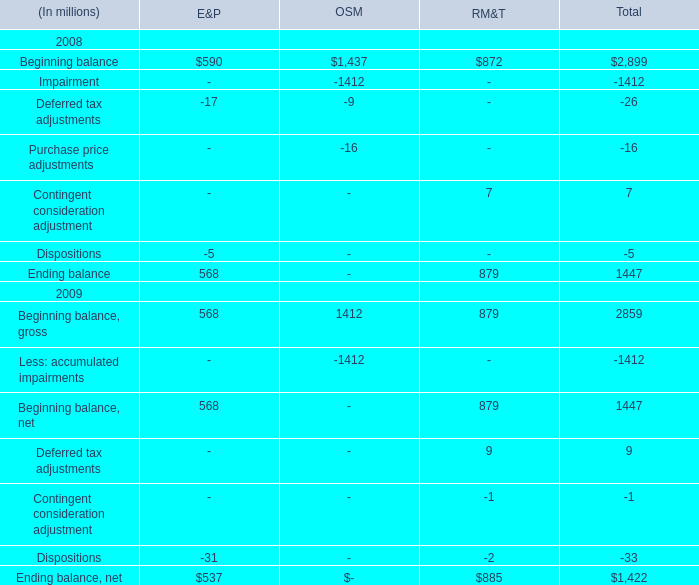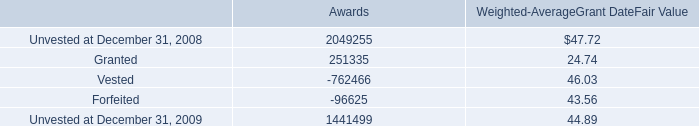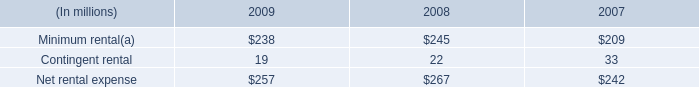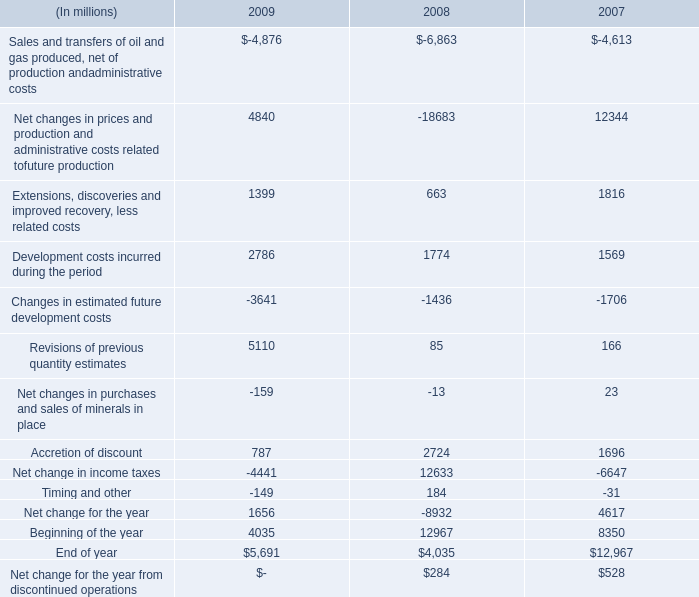What is the sum of Net change in income taxes of 2009, Beginning balance of OSM, and Net changes in prices and production and administrative costs related tofuture production of 2009 ? 
Computations: ((4441.0 + 1437.0) + 4840.0)
Answer: 10718.0. 